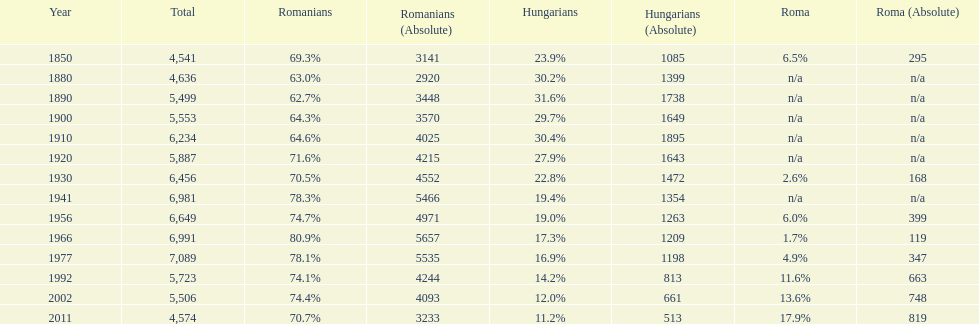Which year had the top percentage in romanian population? 1966. Parse the table in full. {'header': ['Year', 'Total', 'Romanians', 'Romanians (Absolute)', 'Hungarians', 'Hungarians (Absolute)', 'Roma', 'Roma (Absolute)'], 'rows': [['1850', '4,541', '69.3%', '3141', '23.9%', '1085', '6.5%', '295'], ['1880', '4,636', '63.0%', '2920', '30.2%', '1399', 'n/a', 'n/a'], ['1890', '5,499', '62.7%', '3448', '31.6%', '1738', 'n/a', 'n/a'], ['1900', '5,553', '64.3%', '3570', '29.7%', '1649', 'n/a', 'n/a'], ['1910', '6,234', '64.6%', '4025', '30.4%', '1895', 'n/a', 'n/a'], ['1920', '5,887', '71.6%', '4215', '27.9%', '1643', 'n/a', 'n/a'], ['1930', '6,456', '70.5%', '4552', '22.8%', '1472', '2.6%', '168'], ['1941', '6,981', '78.3%', '5466', '19.4%', '1354', 'n/a', 'n/a'], ['1956', '6,649', '74.7%', '4971', '19.0%', '1263', '6.0%', '399'], ['1966', '6,991', '80.9%', '5657', '17.3%', '1209', '1.7%', '119'], ['1977', '7,089', '78.1%', '5535', '16.9%', '1198', '4.9%', '347'], ['1992', '5,723', '74.1%', '4244', '14.2%', '813', '11.6%', '663'], ['2002', '5,506', '74.4%', '4093', '12.0%', '661', '13.6%', '748'], ['2011', '4,574', '70.7%', '3233', '11.2%', '513', '17.9%', '819']]} 